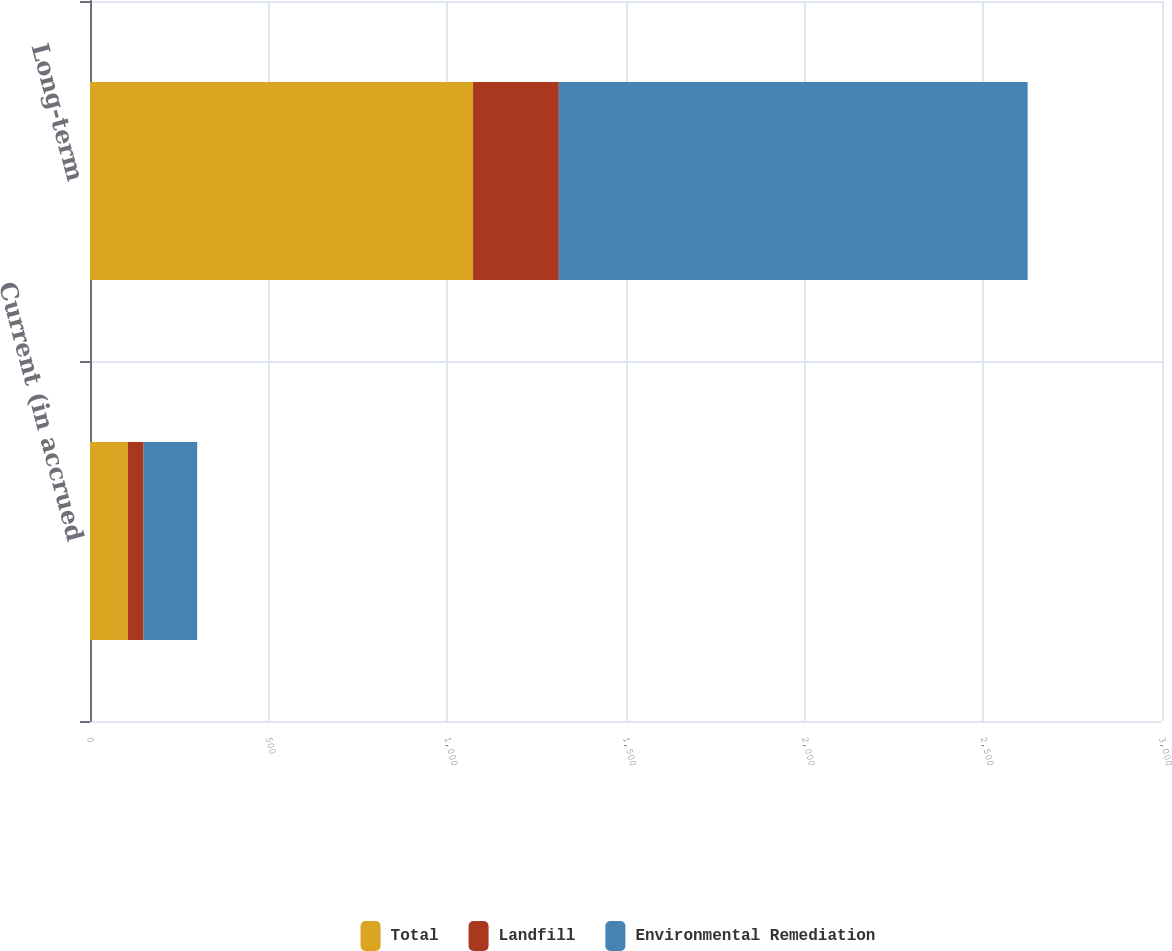Convert chart. <chart><loc_0><loc_0><loc_500><loc_500><stacked_bar_chart><ecel><fcel>Current (in accrued<fcel>Long-term<nl><fcel>Total<fcel>106<fcel>1072<nl><fcel>Landfill<fcel>44<fcel>240<nl><fcel>Environmental Remediation<fcel>150<fcel>1312<nl></chart> 